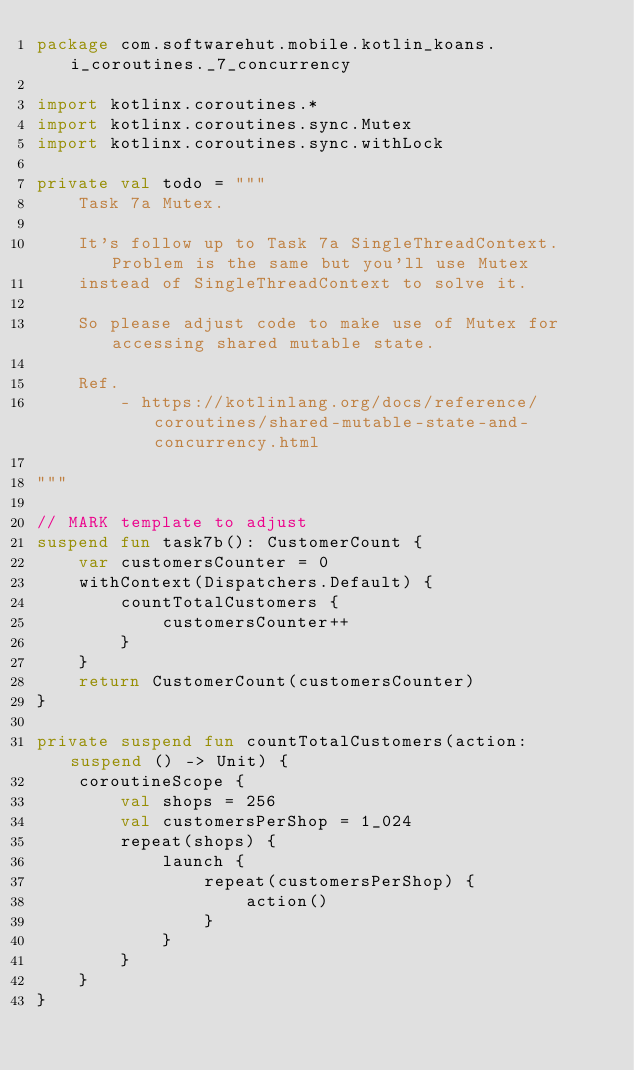Convert code to text. <code><loc_0><loc_0><loc_500><loc_500><_Kotlin_>package com.softwarehut.mobile.kotlin_koans.i_coroutines._7_concurrency

import kotlinx.coroutines.*
import kotlinx.coroutines.sync.Mutex
import kotlinx.coroutines.sync.withLock

private val todo = """
    Task 7a Mutex.
    
    It's follow up to Task 7a SingleThreadContext. Problem is the same but you'll use Mutex
    instead of SingleThreadContext to solve it.
    
    So please adjust code to make use of Mutex for accessing shared mutable state.
    
    Ref.
        - https://kotlinlang.org/docs/reference/coroutines/shared-mutable-state-and-concurrency.html

"""

// MARK template to adjust
suspend fun task7b(): CustomerCount {
    var customersCounter = 0
    withContext(Dispatchers.Default) {
        countTotalCustomers {
            customersCounter++
        }
    }
    return CustomerCount(customersCounter)
}

private suspend fun countTotalCustomers(action: suspend () -> Unit) {
    coroutineScope {
        val shops = 256
        val customersPerShop = 1_024
        repeat(shops) {
            launch {
                repeat(customersPerShop) {
                    action()
                }
            }
        }
    }
}</code> 